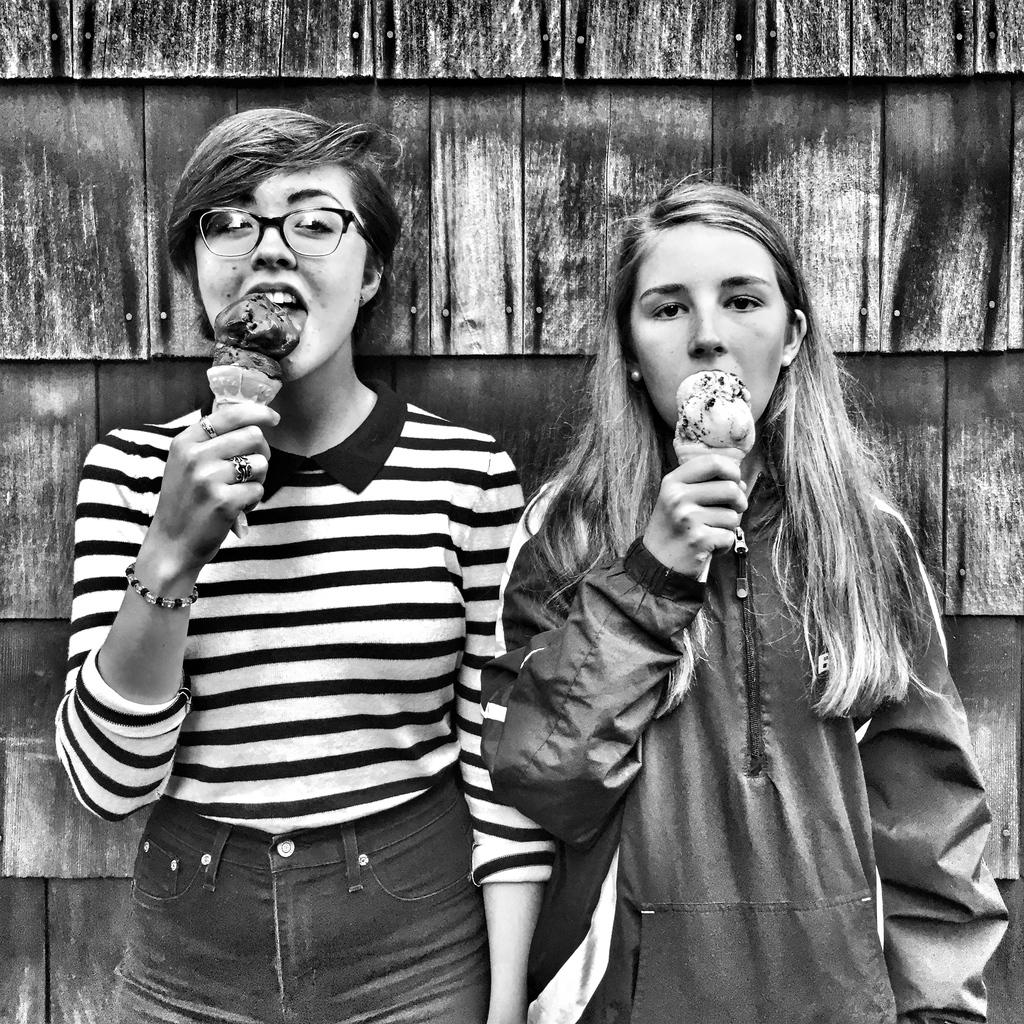How many people are in the image? There are persons in the image, but the exact number is not specified. What is the main object in the image? There is an ice cream in the image. What can be seen in the background of the image? There is a wall in the background of the image. Is there a beggar asking for money near the ice cream in the image? There is no mention of a beggar in the image, so we cannot confirm or deny their presence. 